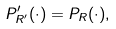<formula> <loc_0><loc_0><loc_500><loc_500>P ^ { \prime } _ { R ^ { \prime } } ( \cdot ) = P _ { R } ( \cdot ) ,</formula> 